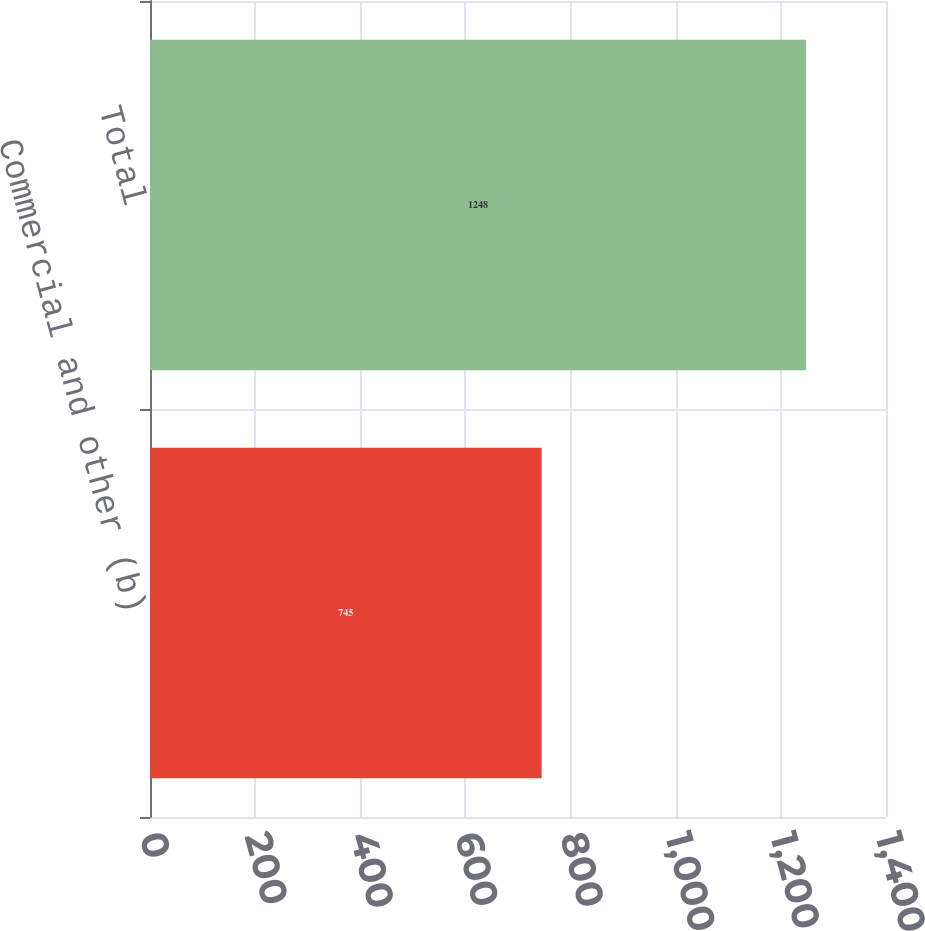Convert chart to OTSL. <chart><loc_0><loc_0><loc_500><loc_500><bar_chart><fcel>Commercial and other (b)<fcel>Total<nl><fcel>745<fcel>1248<nl></chart> 